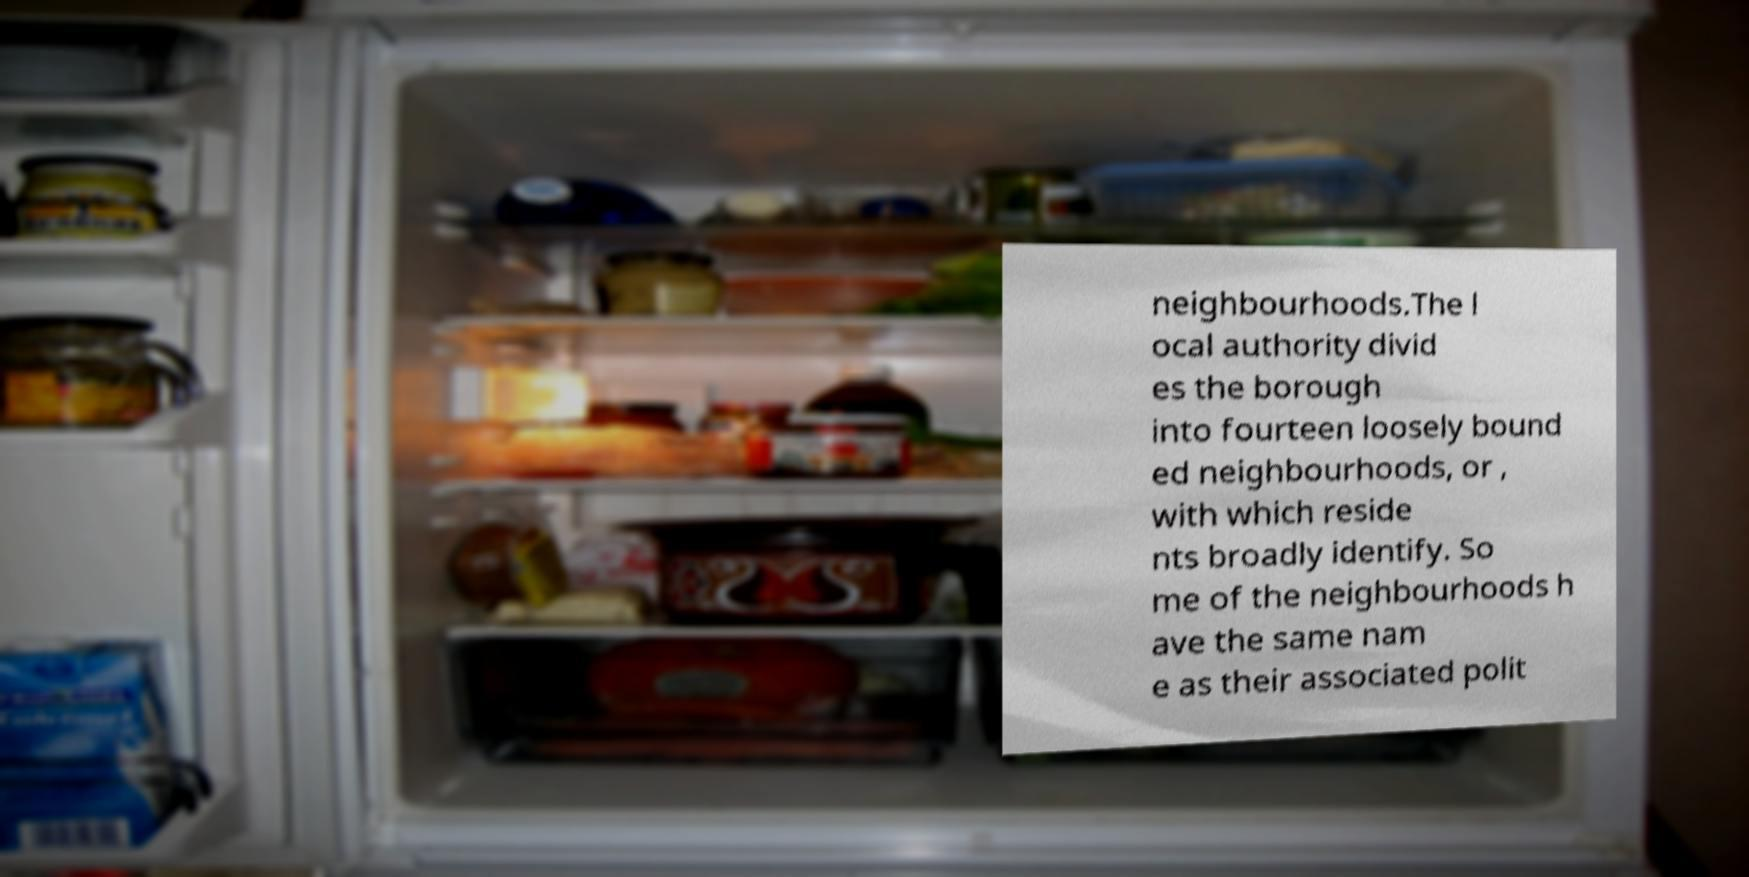Could you extract and type out the text from this image? neighbourhoods.The l ocal authority divid es the borough into fourteen loosely bound ed neighbourhoods, or , with which reside nts broadly identify. So me of the neighbourhoods h ave the same nam e as their associated polit 